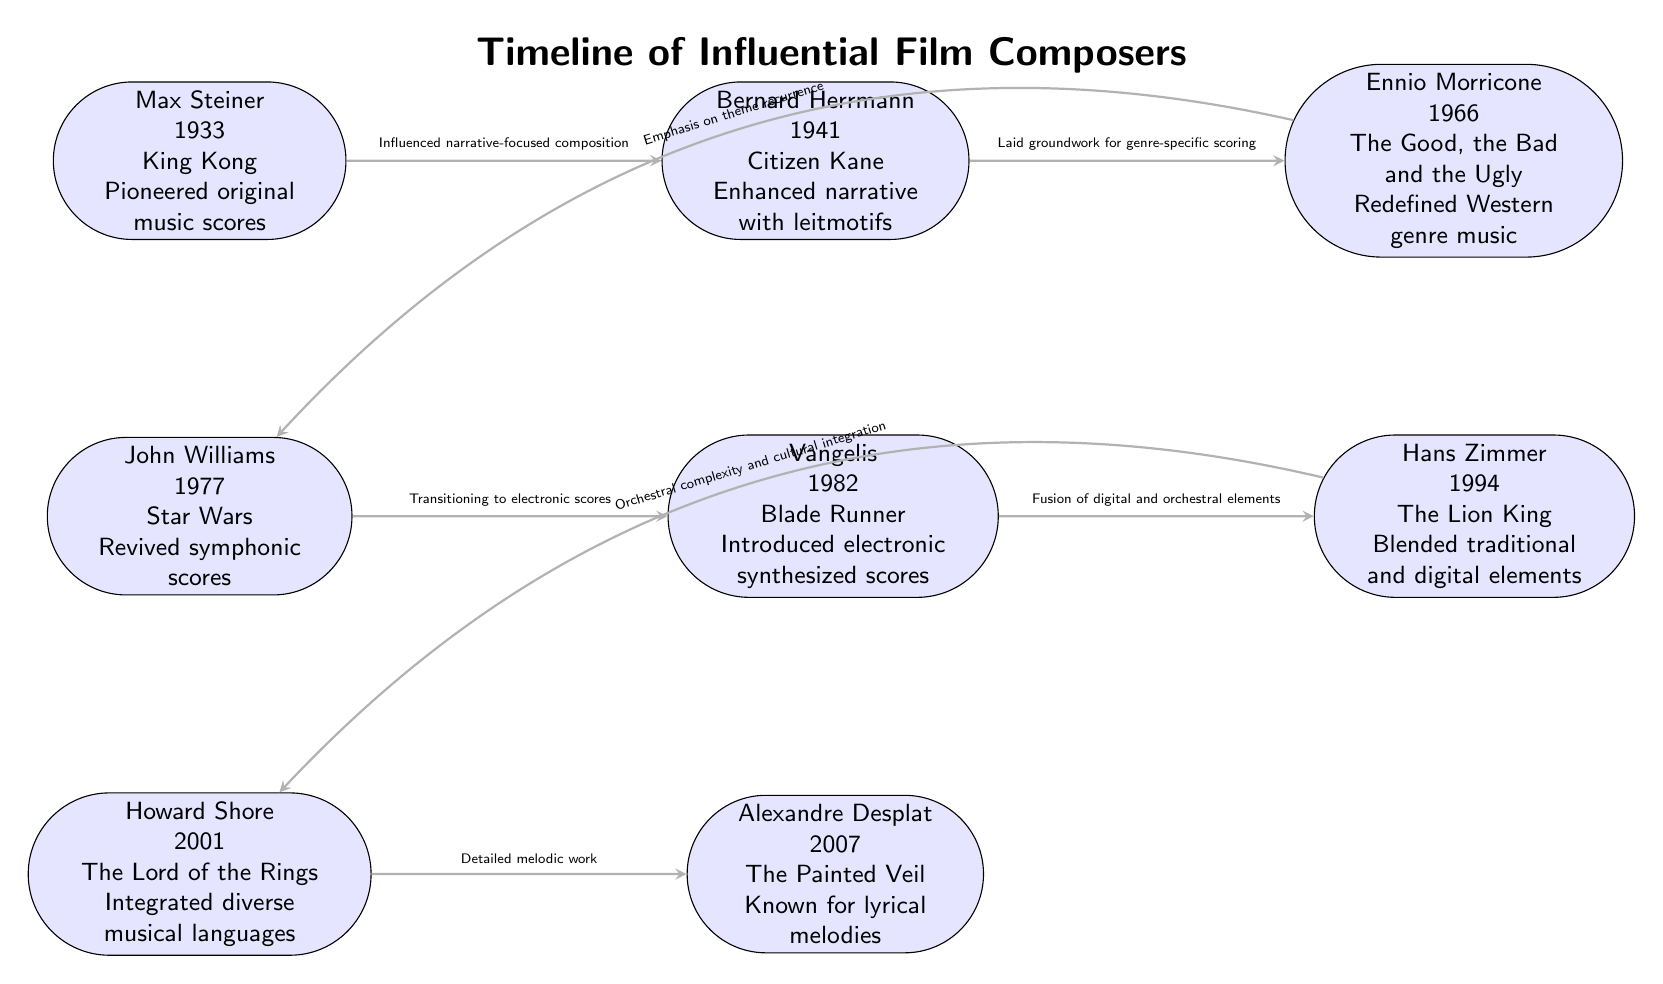What year did Max Steiner compose for King Kong? The diagram states that Max Steiner composed for King Kong in 1933, which is directly indicated next to his name in the node.
Answer: 1933 What film score is associated with Howard Shore? The diagram explicitly lists The Lord of the Rings as the film score associated with Howard Shore in his respective node.
Answer: The Lord of the Rings Which composer is known for integrating diverse musical languages? In the diagram, Howard Shore is identified with integrating diverse musical languages, as per the descriptive text in his node.
Answer: Howard Shore How many influential composers are shown in the timeline? By counting all the composer nodes depicted in the diagram—Max Steiner, Bernard Herrmann, Ennio Morricone, John Williams, Vangelis, Hans Zimmer, Howard Shore, and Alexandre Desplat—a total of eight composers are present.
Answer: 8 What is the relationship between Ennio Morricone and John Williams? The diagram indicates a directed edge from Ennio Morricone to John Williams, which states that Morricone laid groundwork for genre-specific scoring that influenced Williams' work.
Answer: Laid groundwork for genre-specific scoring Which composer is associated with The Painted Veil? According to the diagram, Alexandre Desplat is linked with The Painted Veil, which is mentioned in his node.
Answer: Alexandre Desplat What musical advancement is connected to Hans Zimmer? The diagram notes that Hans Zimmer is known for blending traditional and digital elements, which is the advancement associated with his work according to the text within his node.
Answer: Blended traditional and digital elements How did Vangelis influence the evolution of film scores? The diagram illustrates that Vangelis influenced the evolution of film scores by introducing electronic synthesized scores, which is detailed in his node’s description.
Answer: Introduced electronic synthesized scores What revision did John Williams make to film scoring in 1977? The diagram highlights that John Williams revived symphonic scores, detailing his contribution in the description next to his name.
Answer: Revived symphonic scores 